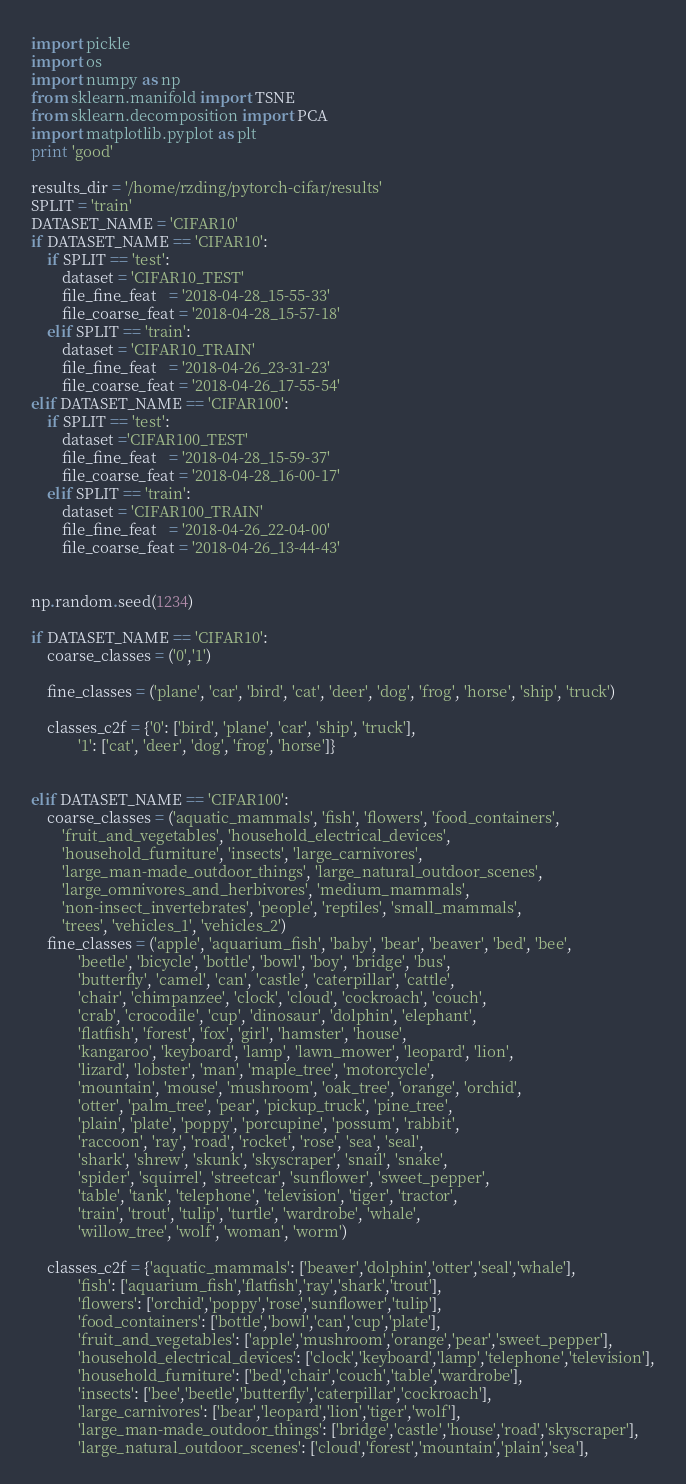<code> <loc_0><loc_0><loc_500><loc_500><_Python_>import pickle
import os
import numpy as np
from sklearn.manifold import TSNE
from sklearn.decomposition import PCA
import matplotlib.pyplot as plt
print 'good'

results_dir = '/home/rzding/pytorch-cifar/results'
SPLIT = 'train'
DATASET_NAME = 'CIFAR10'
if DATASET_NAME == 'CIFAR10':
	if SPLIT == 'test':
		dataset = 'CIFAR10_TEST'
		file_fine_feat   = '2018-04-28_15-55-33'
		file_coarse_feat = '2018-04-28_15-57-18'
	elif SPLIT == 'train':
		dataset = 'CIFAR10_TRAIN'
		file_fine_feat   = '2018-04-26_23-31-23'
		file_coarse_feat = '2018-04-26_17-55-54'
elif DATASET_NAME == 'CIFAR100':
	if SPLIT == 'test':
		dataset ='CIFAR100_TEST' 
		file_fine_feat   = '2018-04-28_15-59-37'
		file_coarse_feat = '2018-04-28_16-00-17'
	elif SPLIT == 'train':
		dataset = 'CIFAR100_TRAIN'
		file_fine_feat   = '2018-04-26_22-04-00'
		file_coarse_feat = '2018-04-26_13-44-43'
	

np.random.seed(1234)

if DATASET_NAME == 'CIFAR10':
	coarse_classes = ('0','1')

	fine_classes = ('plane', 'car', 'bird', 'cat', 'deer', 'dog', 'frog', 'horse', 'ship', 'truck')

	classes_c2f = {'0': ['bird', 'plane', 'car', 'ship', 'truck'],
			'1': ['cat', 'deer', 'dog', 'frog', 'horse']}


elif DATASET_NAME == 'CIFAR100':
	coarse_classes = ('aquatic_mammals', 'fish', 'flowers', 'food_containers',
		'fruit_and_vegetables', 'household_electrical_devices',
		'household_furniture', 'insects', 'large_carnivores',
		'large_man-made_outdoor_things', 'large_natural_outdoor_scenes',
		'large_omnivores_and_herbivores', 'medium_mammals',
		'non-insect_invertebrates', 'people', 'reptiles', 'small_mammals',
		'trees', 'vehicles_1', 'vehicles_2')
	fine_classes = ('apple', 'aquarium_fish', 'baby', 'bear', 'beaver', 'bed', 'bee',
			'beetle', 'bicycle', 'bottle', 'bowl', 'boy', 'bridge', 'bus',
			'butterfly', 'camel', 'can', 'castle', 'caterpillar', 'cattle',
			'chair', 'chimpanzee', 'clock', 'cloud', 'cockroach', 'couch',
			'crab', 'crocodile', 'cup', 'dinosaur', 'dolphin', 'elephant',
			'flatfish', 'forest', 'fox', 'girl', 'hamster', 'house',
			'kangaroo', 'keyboard', 'lamp', 'lawn_mower', 'leopard', 'lion',
			'lizard', 'lobster', 'man', 'maple_tree', 'motorcycle',
			'mountain', 'mouse', 'mushroom', 'oak_tree', 'orange', 'orchid',
			'otter', 'palm_tree', 'pear', 'pickup_truck', 'pine_tree',
			'plain', 'plate', 'poppy', 'porcupine', 'possum', 'rabbit',
			'raccoon', 'ray', 'road', 'rocket', 'rose', 'sea', 'seal',
			'shark', 'shrew', 'skunk', 'skyscraper', 'snail', 'snake',
			'spider', 'squirrel', 'streetcar', 'sunflower', 'sweet_pepper',
			'table', 'tank', 'telephone', 'television', 'tiger', 'tractor',
			'train', 'trout', 'tulip', 'turtle', 'wardrobe', 'whale',
			'willow_tree', 'wolf', 'woman', 'worm')

	classes_c2f = {'aquatic_mammals': ['beaver','dolphin','otter','seal','whale'],
			'fish': ['aquarium_fish','flatfish','ray','shark','trout'],
			'flowers': ['orchid','poppy','rose','sunflower','tulip'],
			'food_containers': ['bottle','bowl','can','cup','plate'],
			'fruit_and_vegetables': ['apple','mushroom','orange','pear','sweet_pepper'],
			'household_electrical_devices': ['clock','keyboard','lamp','telephone','television'],
			'household_furniture': ['bed','chair','couch','table','wardrobe'],
			'insects': ['bee','beetle','butterfly','caterpillar','cockroach'],
			'large_carnivores': ['bear','leopard','lion','tiger','wolf'],
			'large_man-made_outdoor_things': ['bridge','castle','house','road','skyscraper'],
			'large_natural_outdoor_scenes': ['cloud','forest','mountain','plain','sea'],</code> 